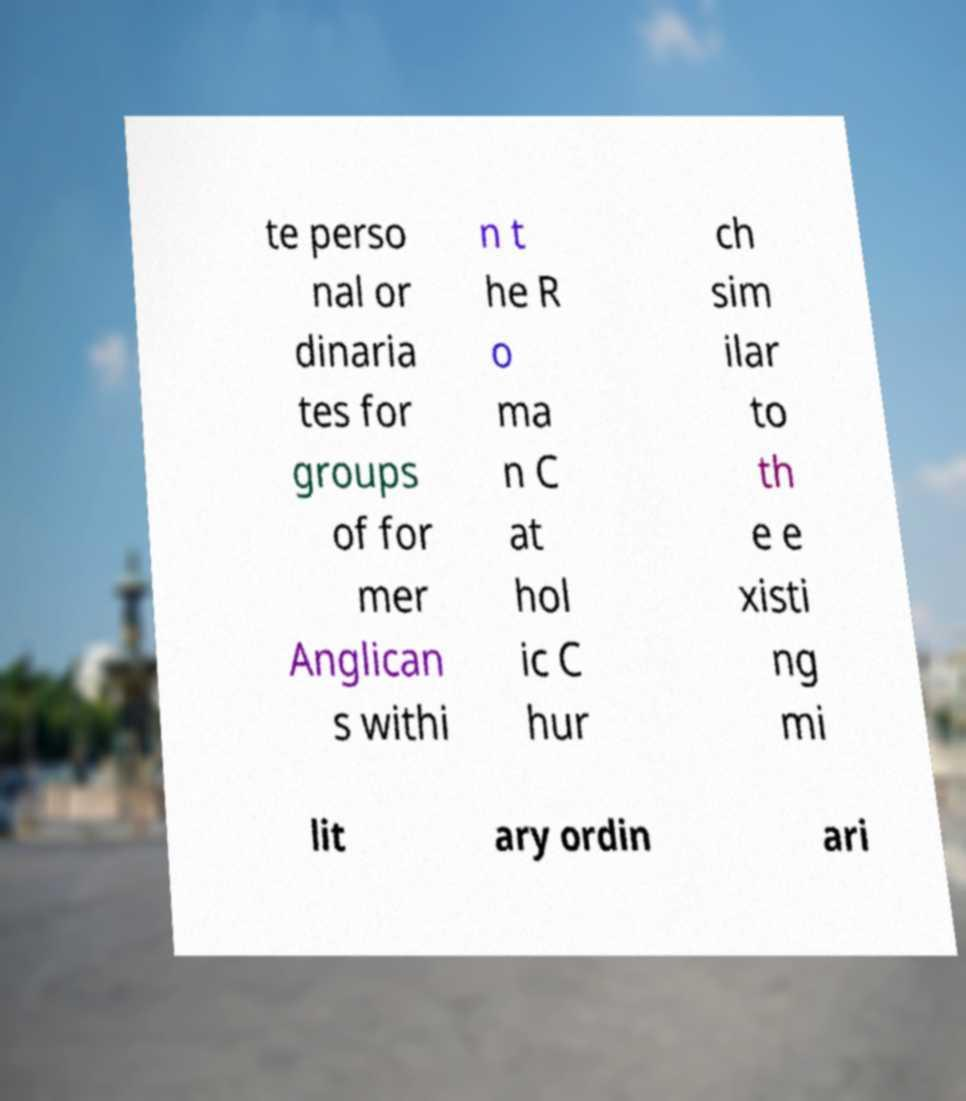Could you extract and type out the text from this image? te perso nal or dinaria tes for groups of for mer Anglican s withi n t he R o ma n C at hol ic C hur ch sim ilar to th e e xisti ng mi lit ary ordin ari 